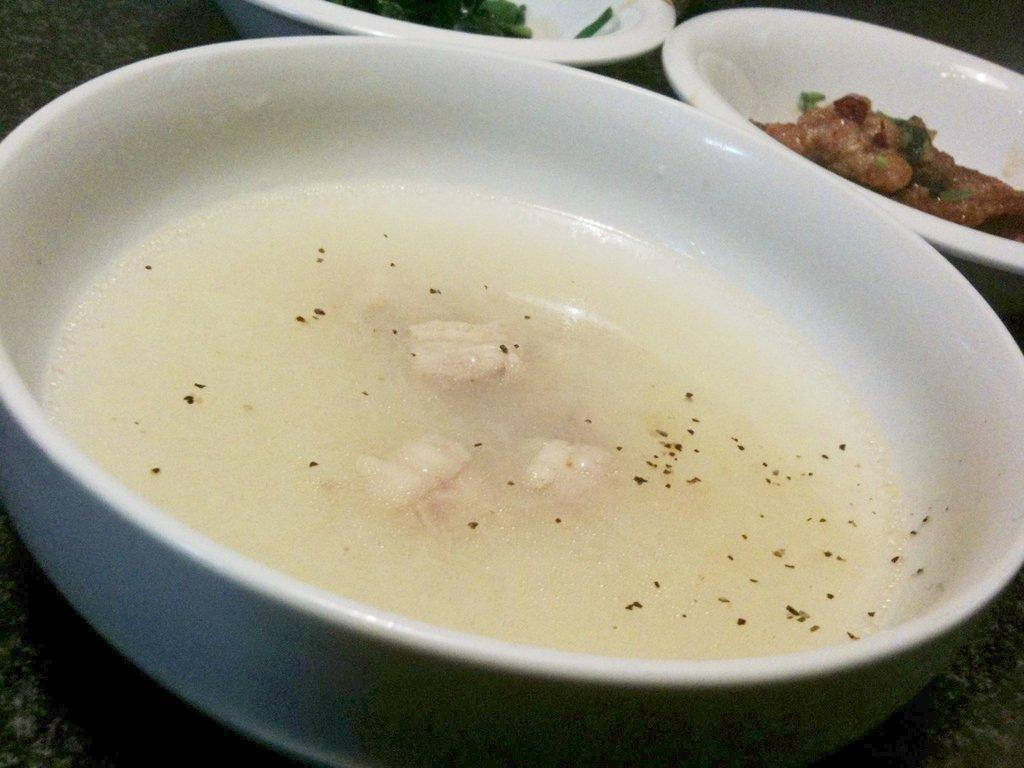How many bowls are visible in the image? There are three bowls in the image. What type of food is present in the bowls? There is food in the bowls, including soup in at least one of them. What type of yarn is used to create the soup in the image? There is no yarn present in the image, and soup is not made from yarn. 